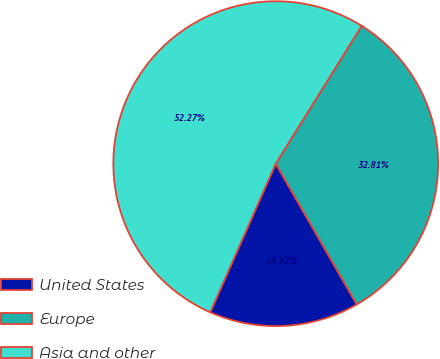Convert chart to OTSL. <chart><loc_0><loc_0><loc_500><loc_500><pie_chart><fcel>United States<fcel>Europe<fcel>Asia and other<nl><fcel>14.92%<fcel>32.81%<fcel>52.27%<nl></chart> 